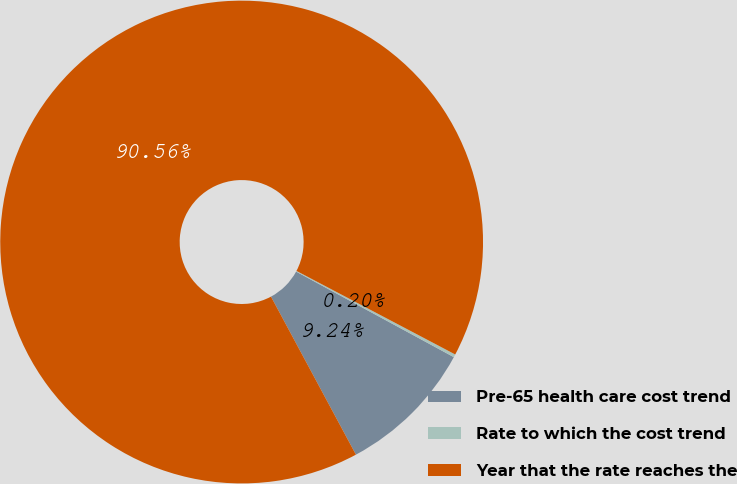Convert chart to OTSL. <chart><loc_0><loc_0><loc_500><loc_500><pie_chart><fcel>Pre-65 health care cost trend<fcel>Rate to which the cost trend<fcel>Year that the rate reaches the<nl><fcel>9.24%<fcel>0.2%<fcel>90.56%<nl></chart> 